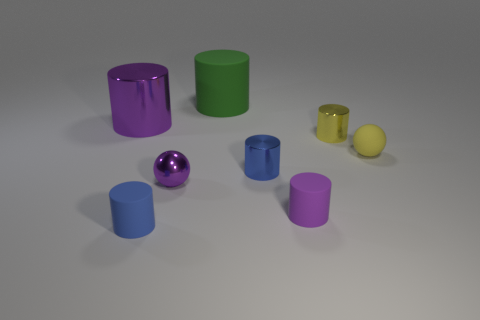Which objects in the image reflect light the most? The shiny purple cylinder and the small shiny purple sphere reflect light the most, giving them a glossy appearance. 